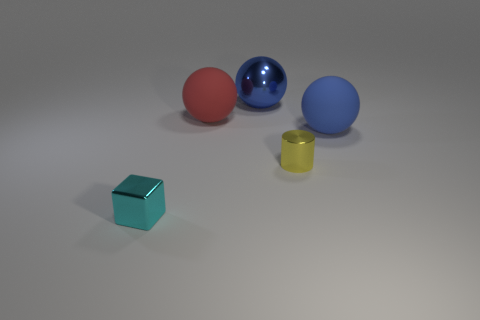Is there anything else that is the same material as the cylinder?
Offer a very short reply. Yes. The red rubber ball has what size?
Ensure brevity in your answer.  Large. What material is the cylinder?
Your answer should be very brief. Metal. Do the matte sphere on the left side of the blue matte sphere and the yellow cylinder have the same size?
Your answer should be compact. No. What number of things are small green metal blocks or big blue objects?
Make the answer very short. 2. There is a thing that is left of the big blue shiny thing and behind the cylinder; what size is it?
Keep it short and to the point. Large. How many red shiny blocks are there?
Ensure brevity in your answer.  0. How many blocks are either large yellow shiny things or matte objects?
Offer a terse response. 0. How many shiny things are behind the matte sphere that is to the left of the tiny metal object that is on the right side of the cube?
Give a very brief answer. 1. What color is the cylinder that is the same size as the cyan cube?
Ensure brevity in your answer.  Yellow. 